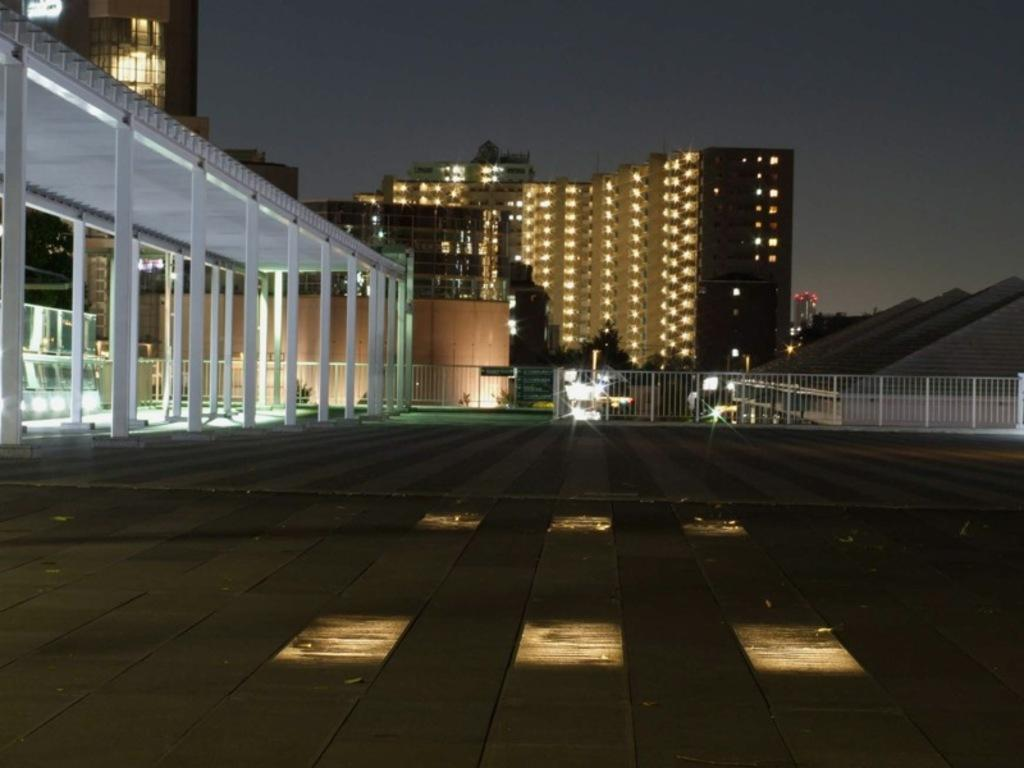What type of structures can be seen in the image? There are buildings in the image. What can be observed illuminating the scene in the image? There are lights visible in the image. Can you describe any architectural features in the image? There are pillars with roofs in the image. What type of barrier is present in the image? There is fencing in the image. Where is the owl sitting in the image? There is no owl present in the image. What type of chair can be seen in the image? There is no chair present in the image. 